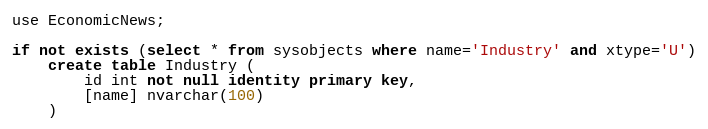<code> <loc_0><loc_0><loc_500><loc_500><_SQL_>use EconomicNews;

if not exists (select * from sysobjects where name='Industry' and xtype='U')
    create table Industry (
        id int not null identity primary key,
		[name] nvarchar(100)
    )</code> 